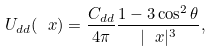Convert formula to latex. <formula><loc_0><loc_0><loc_500><loc_500>U _ { d d } ( \ x ) = \frac { C _ { d d } } { 4 \pi } \frac { 1 - 3 \cos ^ { 2 } \theta } { | \ x | ^ { 3 } } ,</formula> 